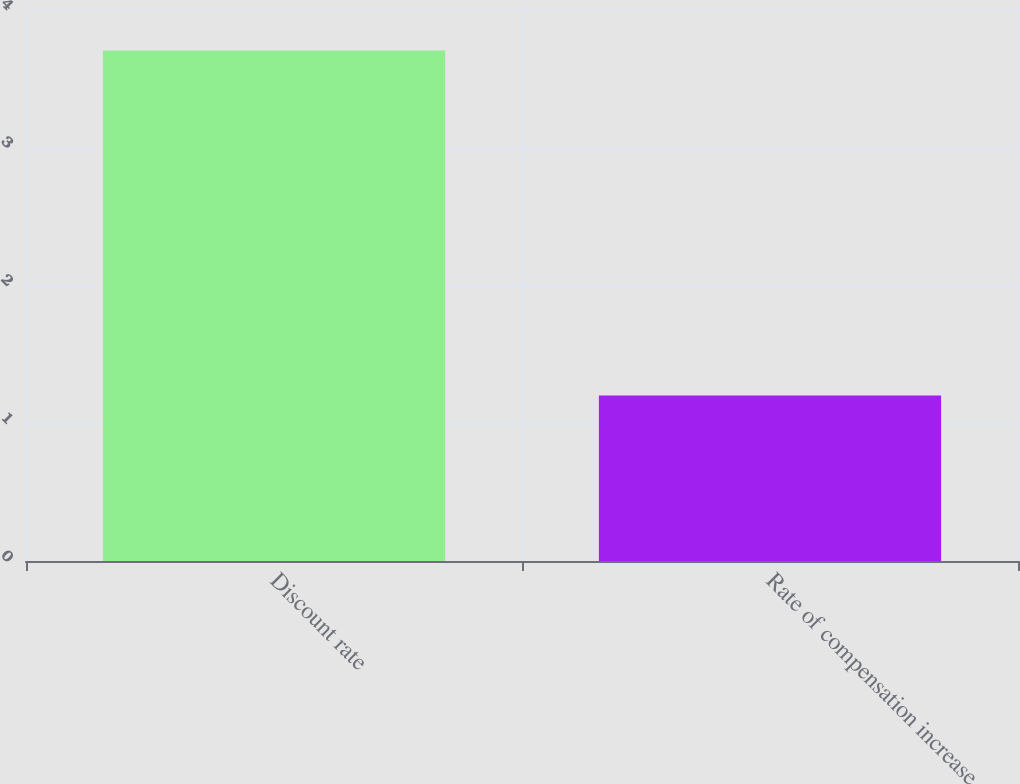<chart> <loc_0><loc_0><loc_500><loc_500><bar_chart><fcel>Discount rate<fcel>Rate of compensation increase<nl><fcel>3.7<fcel>1.2<nl></chart> 